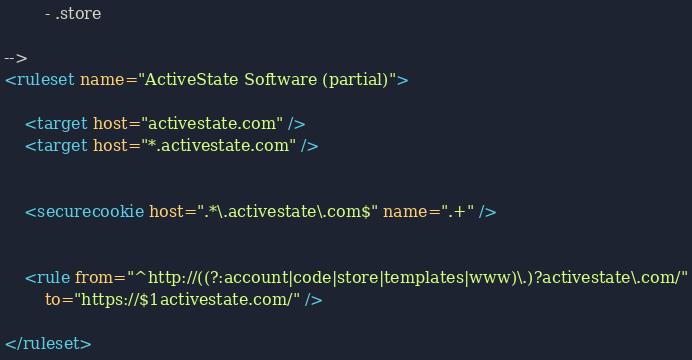<code> <loc_0><loc_0><loc_500><loc_500><_XML_>		- .store

-->
<ruleset name="ActiveState Software (partial)">

	<target host="activestate.com" />
	<target host="*.activestate.com" />


	<securecookie host=".*\.activestate\.com$" name=".+" />


	<rule from="^http://((?:account|code|store|templates|www)\.)?activestate\.com/"
		to="https://$1activestate.com/" />

</ruleset>
</code> 